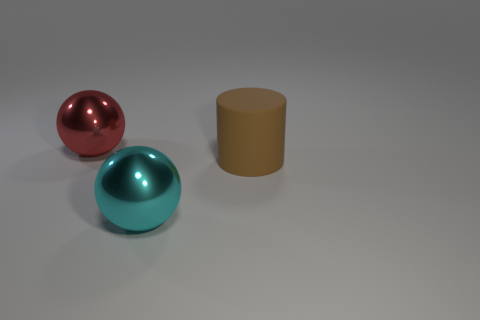Is the shape of the large metal thing in front of the big red shiny sphere the same as  the large brown object?
Give a very brief answer. No. How many other brown matte cylinders are the same size as the rubber cylinder?
Your response must be concise. 0. What number of red shiny balls are in front of the big shiny object that is to the right of the large red metallic object?
Offer a very short reply. 0. Are the cyan ball left of the matte object and the red sphere made of the same material?
Your answer should be very brief. Yes. Is the material of the large object in front of the big brown cylinder the same as the large ball behind the brown rubber cylinder?
Provide a succinct answer. Yes. Are there more red metal balls in front of the matte cylinder than balls?
Provide a succinct answer. No. The thing that is to the right of the large metallic sphere in front of the big rubber thing is what color?
Offer a very short reply. Brown. There is a brown thing that is the same size as the red metallic sphere; what is its shape?
Offer a very short reply. Cylinder. Is the number of cyan shiny things that are behind the cyan ball the same as the number of rubber objects?
Provide a succinct answer. No. What is the material of the ball that is behind the big metal thing that is in front of the large metal thing behind the cyan sphere?
Keep it short and to the point. Metal. 